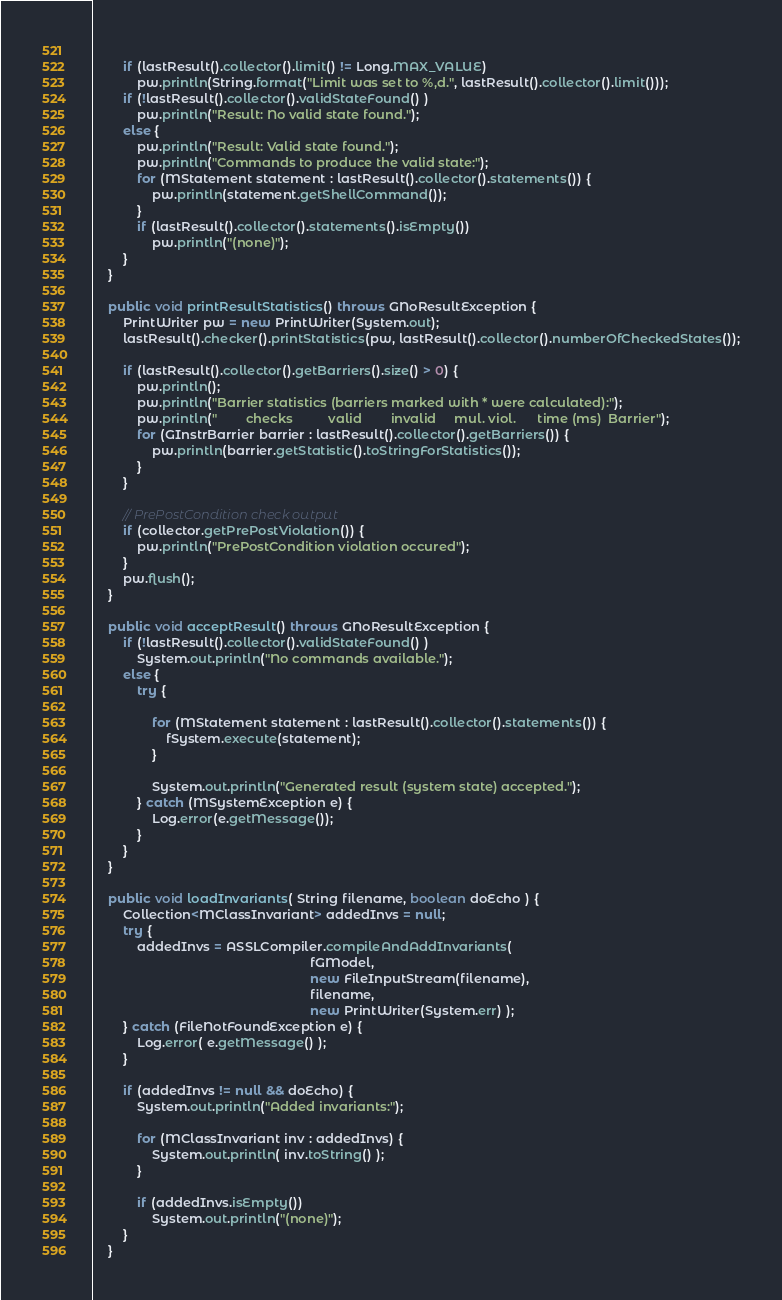Convert code to text. <code><loc_0><loc_0><loc_500><loc_500><_Java_>        
        if (lastResult().collector().limit() != Long.MAX_VALUE)
            pw.println(String.format("Limit was set to %,d.", lastResult().collector().limit()));
        if (!lastResult().collector().validStateFound() )
            pw.println("Result: No valid state found.");
        else {
            pw.println("Result: Valid state found.");
            pw.println("Commands to produce the valid state:");
            for (MStatement statement : lastResult().collector().statements()) {
            	pw.println(statement.getShellCommand());
            }     
            if (lastResult().collector().statements().isEmpty())
                pw.println("(none)");
        }
    }
    
    public void printResultStatistics() throws GNoResultException {
        PrintWriter pw = new PrintWriter(System.out);
        lastResult().checker().printStatistics(pw, lastResult().collector().numberOfCheckedStates());
        
        if (lastResult().collector().getBarriers().size() > 0) {
        	pw.println();
        	pw.println("Barrier statistics (barriers marked with * were calculated):");
        	pw.println("        checks          valid        invalid     mul. viol.      time (ms)  Barrier");
        	for (GInstrBarrier barrier : lastResult().collector().getBarriers()) {
        		pw.println(barrier.getStatistic().toStringForStatistics());
        	}
        }
        
        // PrePostCondition check output
        if (collector.getPrePostViolation()) {
        	pw.println("PrePostCondition violation occured");
        }
        pw.flush();
    }
    
    public void acceptResult() throws GNoResultException {
        if (!lastResult().collector().validStateFound() )
            System.out.println("No commands available.");
        else {
            try {
               
                for (MStatement statement : lastResult().collector().statements()) {
                	fSystem.execute(statement);
                }
                
                System.out.println("Generated result (system state) accepted.");
            } catch (MSystemException e) {
            	Log.error(e.getMessage());
			}
        }
    }

    public void loadInvariants( String filename, boolean doEcho ) {
        Collection<MClassInvariant> addedInvs = null;
        try {
            addedInvs = ASSLCompiler.compileAndAddInvariants(
                                                            fGModel,
                                                            new FileInputStream(filename),
                                                            filename,
                                                            new PrintWriter(System.err) );
        } catch (FileNotFoundException e) {
            Log.error( e.getMessage() );
        }
        
        if (addedInvs != null && doEcho) {
            System.out.println("Added invariants:");
            
            for (MClassInvariant inv : addedInvs) {
            	System.out.println( inv.toString() );
            }
            
            if (addedInvs.isEmpty())
                System.out.println("(none)");
        }
    }
</code> 